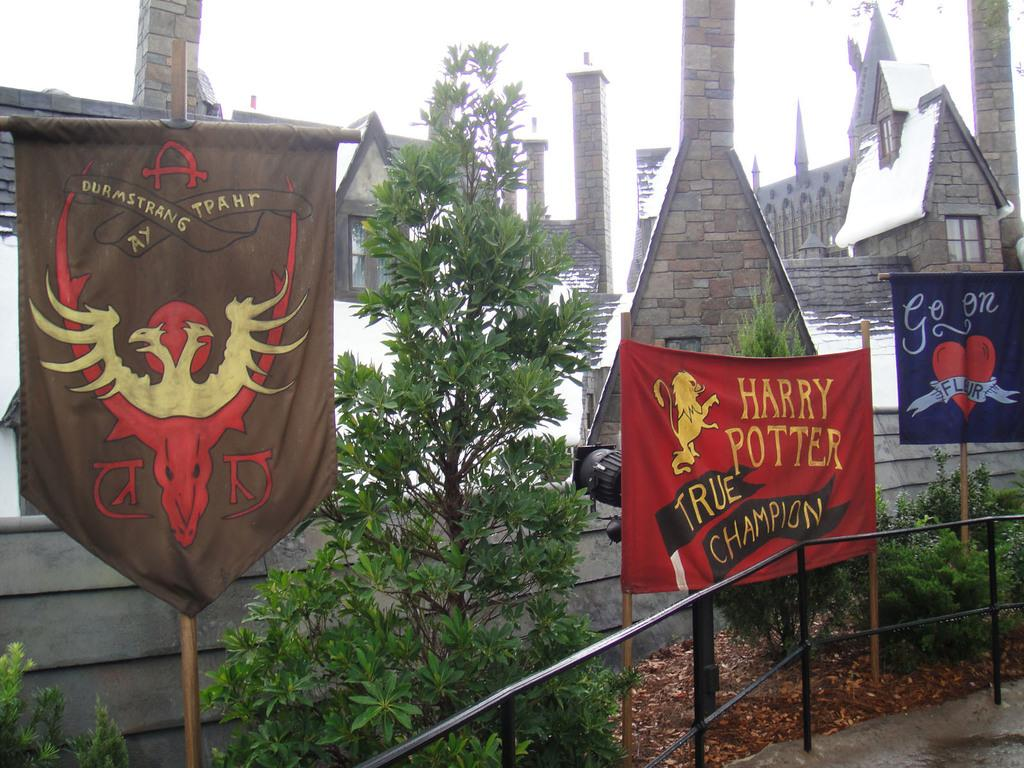<image>
Present a compact description of the photo's key features. Come to view the castle who recreate the legend of Harry Potter. 